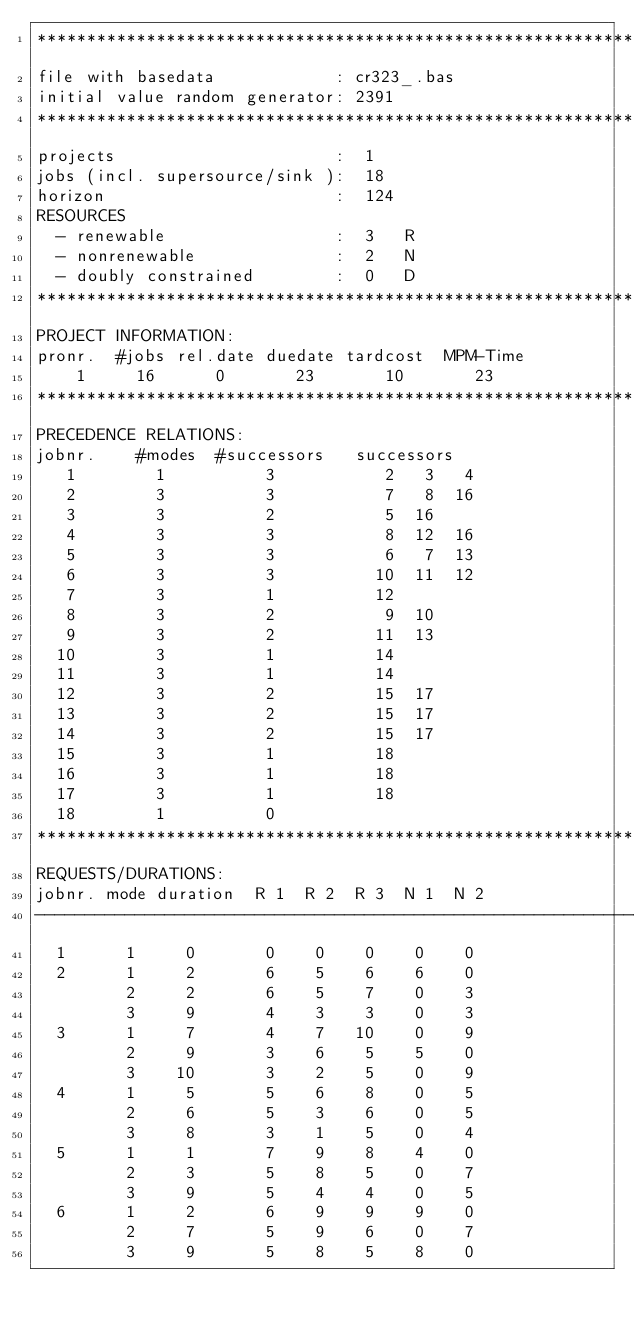Convert code to text. <code><loc_0><loc_0><loc_500><loc_500><_ObjectiveC_>************************************************************************
file with basedata            : cr323_.bas
initial value random generator: 2391
************************************************************************
projects                      :  1
jobs (incl. supersource/sink ):  18
horizon                       :  124
RESOURCES
  - renewable                 :  3   R
  - nonrenewable              :  2   N
  - doubly constrained        :  0   D
************************************************************************
PROJECT INFORMATION:
pronr.  #jobs rel.date duedate tardcost  MPM-Time
    1     16      0       23       10       23
************************************************************************
PRECEDENCE RELATIONS:
jobnr.    #modes  #successors   successors
   1        1          3           2   3   4
   2        3          3           7   8  16
   3        3          2           5  16
   4        3          3           8  12  16
   5        3          3           6   7  13
   6        3          3          10  11  12
   7        3          1          12
   8        3          2           9  10
   9        3          2          11  13
  10        3          1          14
  11        3          1          14
  12        3          2          15  17
  13        3          2          15  17
  14        3          2          15  17
  15        3          1          18
  16        3          1          18
  17        3          1          18
  18        1          0        
************************************************************************
REQUESTS/DURATIONS:
jobnr. mode duration  R 1  R 2  R 3  N 1  N 2
------------------------------------------------------------------------
  1      1     0       0    0    0    0    0
  2      1     2       6    5    6    6    0
         2     2       6    5    7    0    3
         3     9       4    3    3    0    3
  3      1     7       4    7   10    0    9
         2     9       3    6    5    5    0
         3    10       3    2    5    0    9
  4      1     5       5    6    8    0    5
         2     6       5    3    6    0    5
         3     8       3    1    5    0    4
  5      1     1       7    9    8    4    0
         2     3       5    8    5    0    7
         3     9       5    4    4    0    5
  6      1     2       6    9    9    9    0
         2     7       5    9    6    0    7
         3     9       5    8    5    8    0</code> 